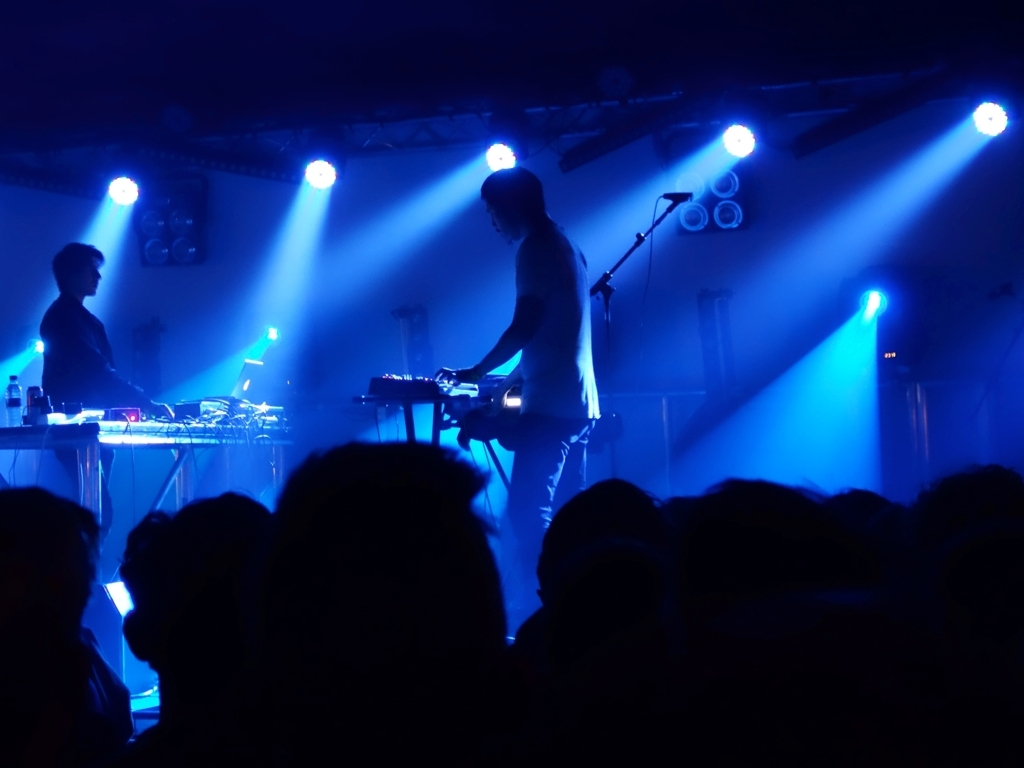Is the image sharp? The image is not sharp; it has a blurry quality likely due to the movement in the scene, low lighting, or camera focus settings—common challenges in concert photography. 